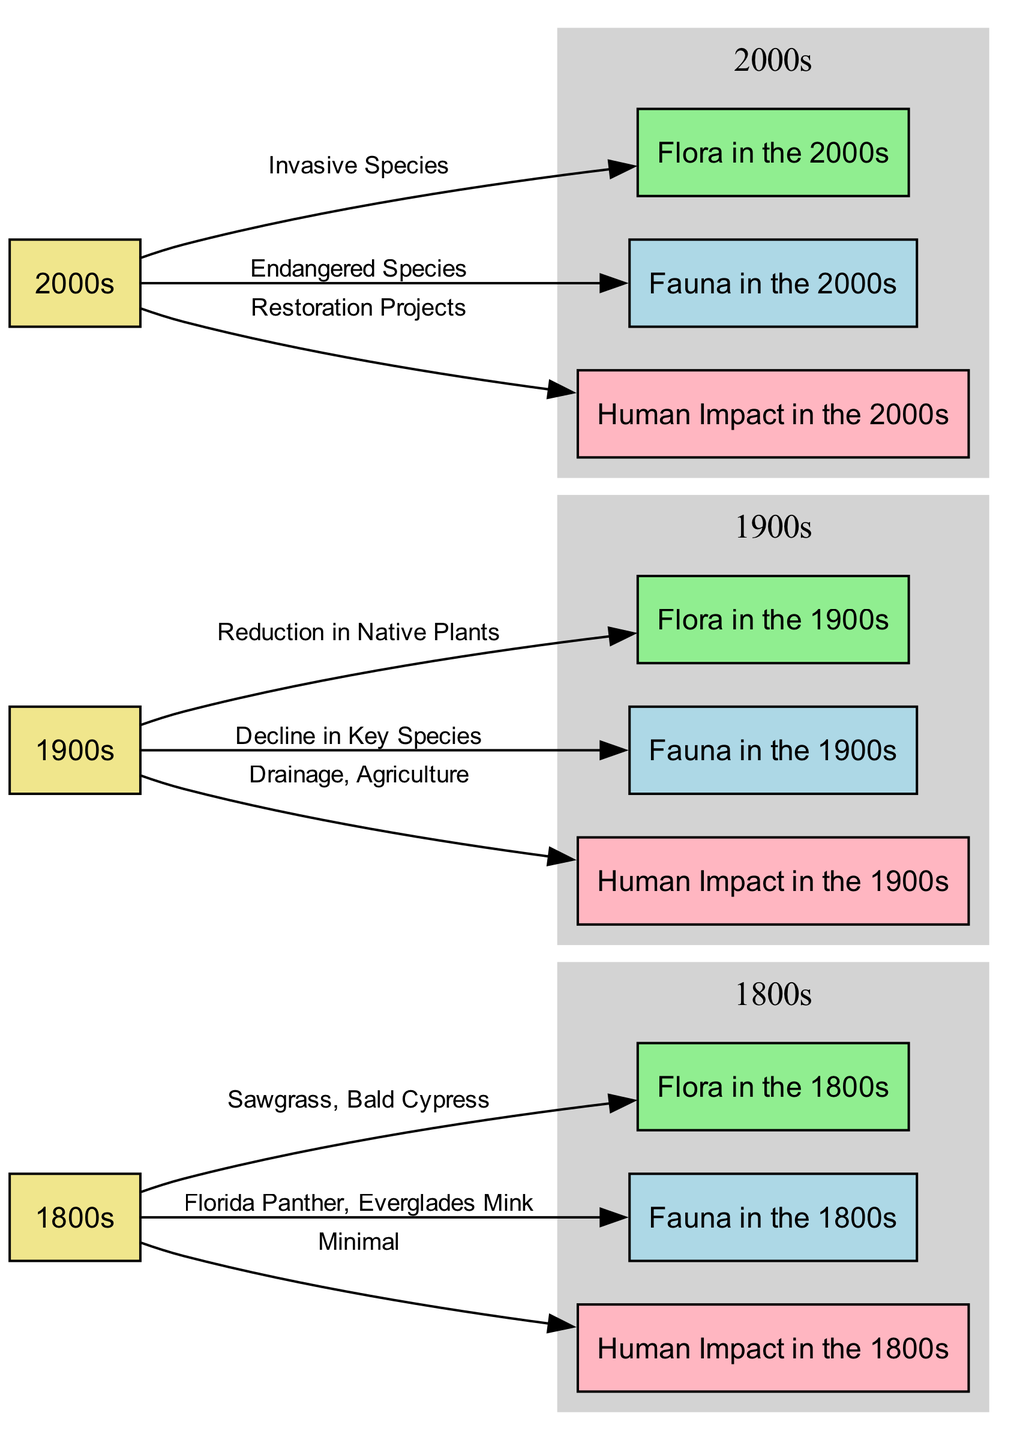What flora was present in the 1800s? The diagram indicates that the flora in the 1800s consisted of Sawgrass and Bald Cypress, which are explicitly mentioned in the edge connecting the "1800s" node to the "Flora in the 1800s" node.
Answer: Sawgrass, Bald Cypress What was the human impact in the 1900s? The diagram shows that the human impact in the 1900s was characterized by Drainage and Agriculture, as specified in the edge leading from the "1900s" node to the "Human Impact in the 1900s" node.
Answer: Drainage, Agriculture How many nodes represent human impact? In the diagram, there are three distinct nodes that represent human impact for each of the time periods: "Human Impact in the 1800s," "Human Impact in the 1900s," and "Human Impact in the 2000s." Counting these gives us a total of three nodes.
Answer: 3 What fauna species were present in the 2000s? The edge connecting "2000s" to "Fauna in the 2000s" specifies that the fauna included Endangered Species, which directly answers the question.
Answer: Endangered Species What change occurred in flora from the 1800s to the 1900s? The transition from the flora of the 1800s to the flora of the 1900s shows a "Reduction in Native Plants," which is stated in the edge between the "1900s" node and the "Flora in the 1900s" node, indicating a significant ecological shift.
Answer: Reduction in Native Plants What were the two key fauna present in the 1800s? According to the edge from "1800s" to "Fauna in the 1800s," the key fauna species were the Florida Panther and the Everglades Mink, which clearly represent the wildlife present during this period.
Answer: Florida Panther, Everglades Mink What trend in human impact can be observed from the 1800s to the 2000s? Analyzing the edges, the trend indicates an evolution from "Minimal" human impact in the 1800s to "Drainage, Agriculture" in the 1900s, and then to "Restoration Projects" in the 2000s, suggesting a shift from disruptive practices to efforts aimed at ecological recovery.
Answer: Minimal to Restoration Projects What illustrates the main threat to fauna in the 1900s? The decline in key species is highlighted in the connection between the "1900s" node and "Fauna in the 1900s," indicating that this was a significant risk period for wildlife during the 20th century.
Answer: Decline in Key Species 